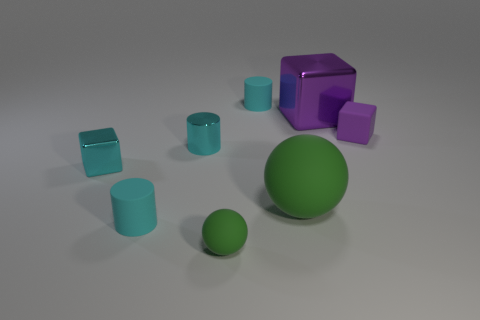Are there any indications about the lighting source in this composition? Indeed, the consistent shading and highlights on the objects suggest a single, diffuse light source located above and slightly to the right of the scene, which casts soft shadows below and to the left of each object.  What might be the purpose of this image with these objects? This image could serve multiple purposes: it may be a 3D rendering showcasing object design, lighting effects, and texture work, or it might be used as an educational tool to demonstrate concepts like geometry, spatial relationships, or color theory. 